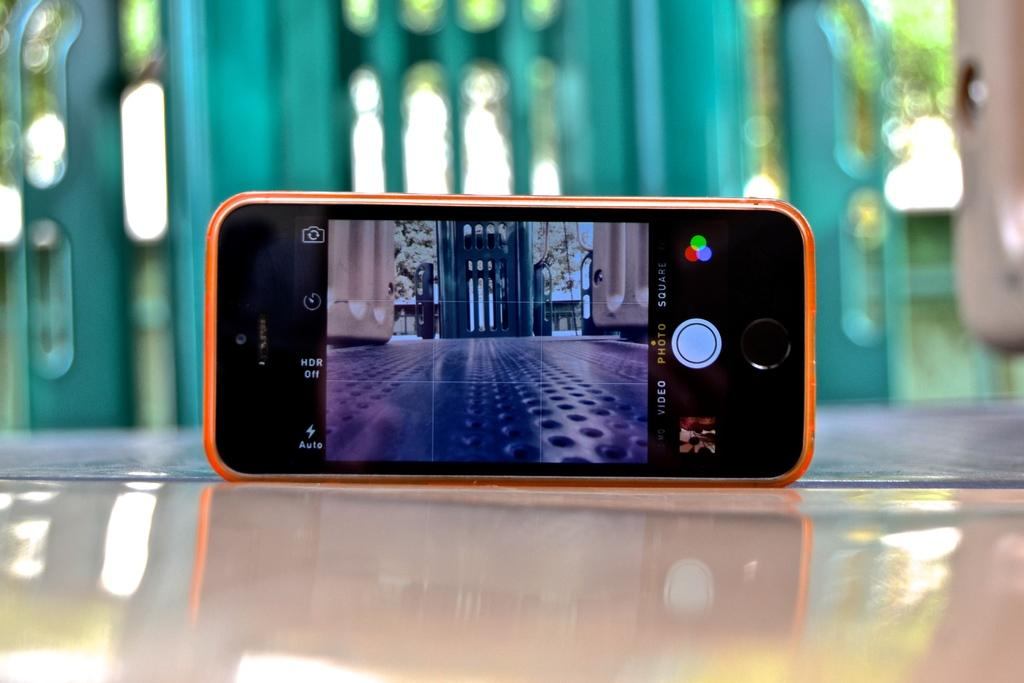<image>
Share a concise interpretation of the image provided. A smartphone with an orange case on the camera setting and it says HDR off. 